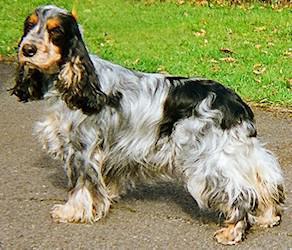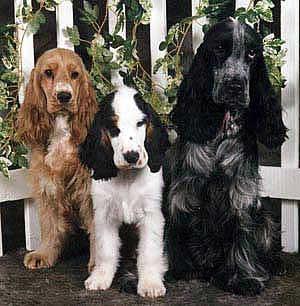The first image is the image on the left, the second image is the image on the right. For the images shown, is this caption "The right image features one orange cocker spaniel standing on all fours in profile, and the left image features a spaniel with dark fur on the ears and eyes and lighter body fur." true? Answer yes or no. No. The first image is the image on the left, the second image is the image on the right. Considering the images on both sides, is "One dog's body is turned towards the right." valid? Answer yes or no. No. 